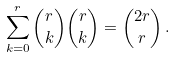<formula> <loc_0><loc_0><loc_500><loc_500>\sum _ { k = 0 } ^ { r } { r \choose k } { r \choose k } = { 2 r \choose r } \, .</formula> 